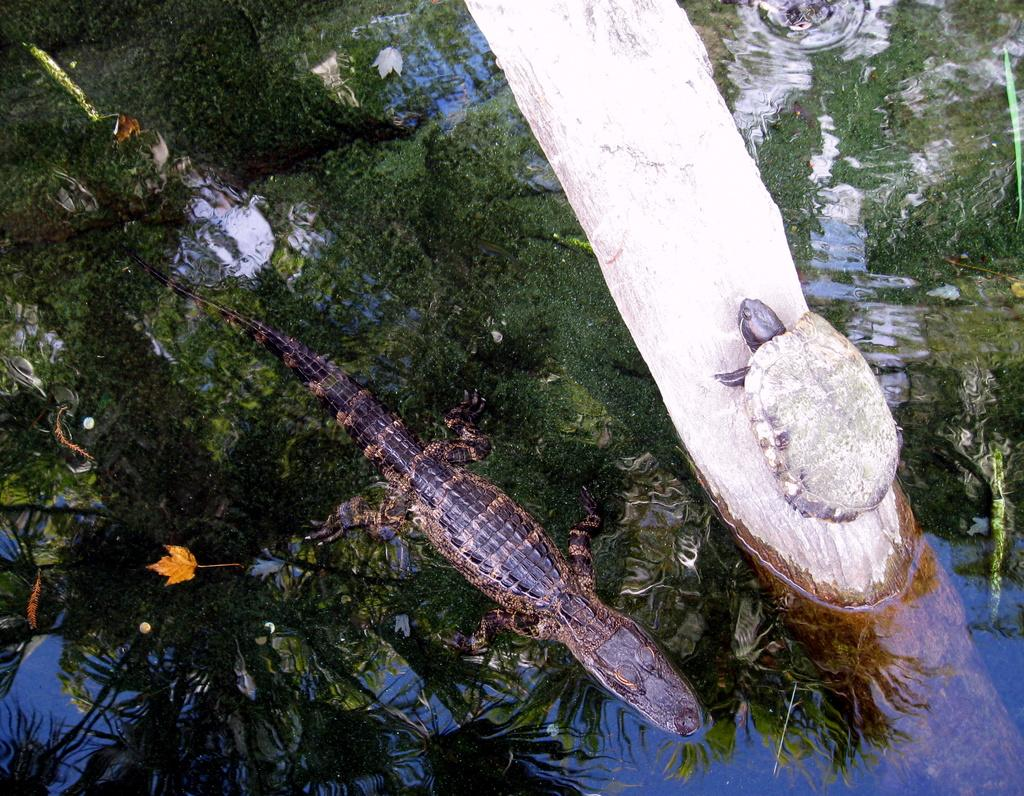What is present in the image that represents a natural body of water? There is water in the image. What type of animal can be seen in the water? There is a crocodile in the image. What other type of animal can be seen in the water? There is a turtle in the image. What type of tin can be seen in the image? There is no tin present in the image. Can you see a window in the image? There is no window present in the image. 